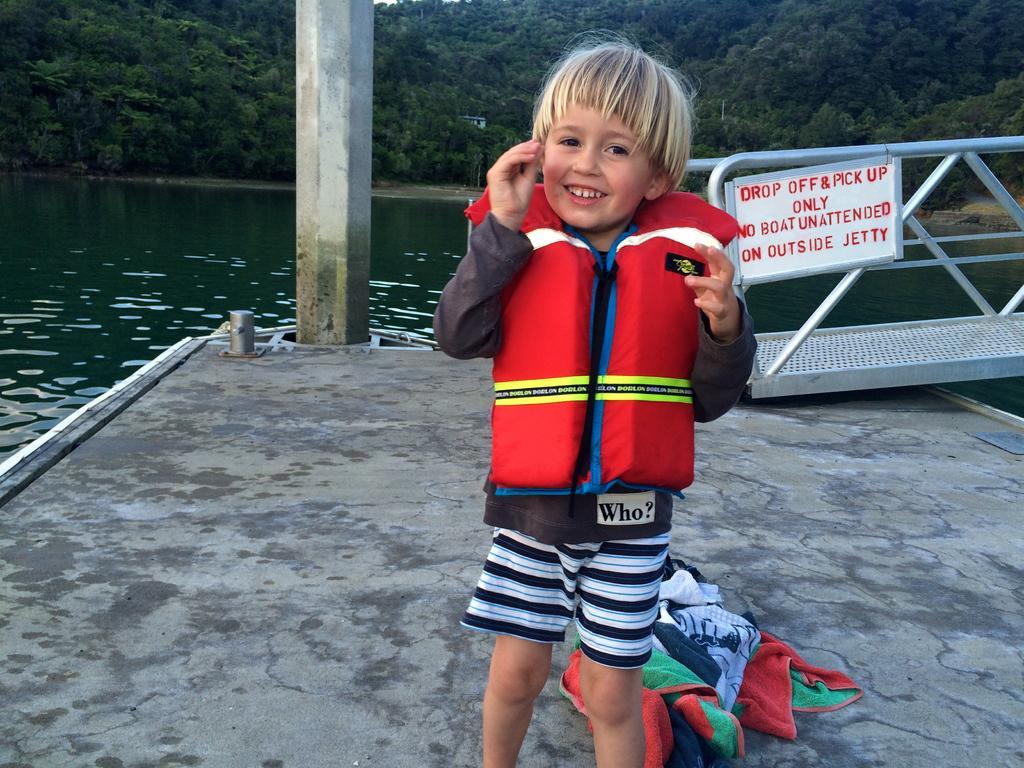Can you describe this image briefly? In this picture we can see a child wore a jacket and smiling and at the back of this child we can see clothes on the floor, name board, water, pillar, rods and some objects and in the background we can see trees. 